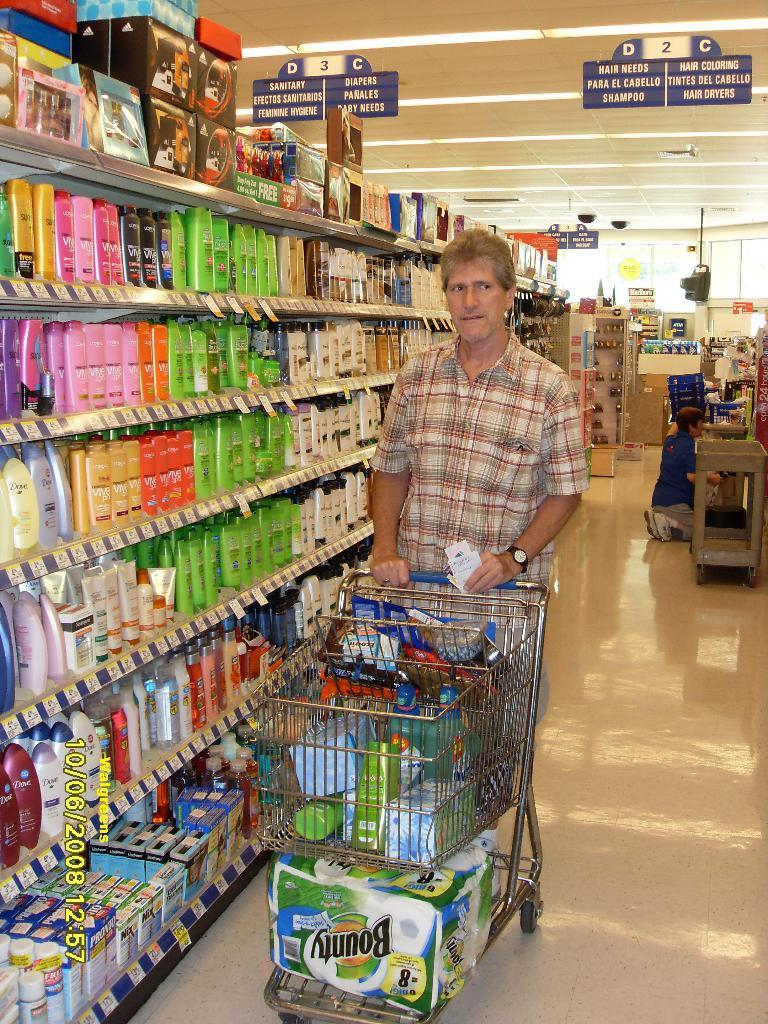<image>
Offer a succinct explanation of the picture presented. A man is shopping and has a large package of Bounty paper towels in his car. 